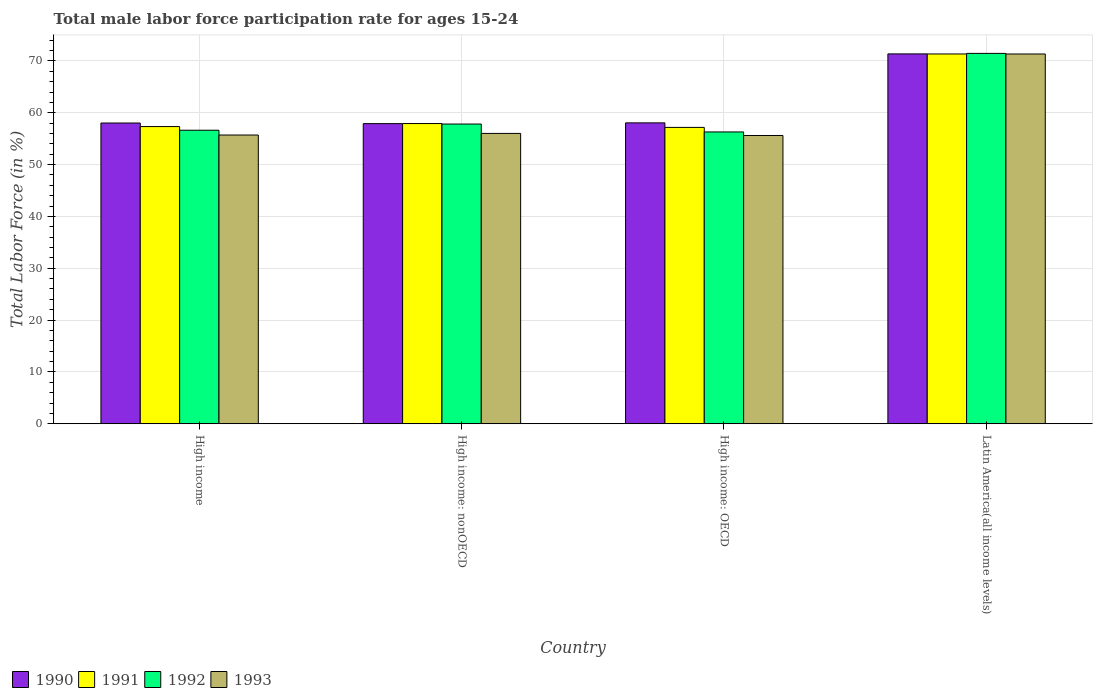How many different coloured bars are there?
Make the answer very short. 4. How many groups of bars are there?
Provide a succinct answer. 4. Are the number of bars on each tick of the X-axis equal?
Your answer should be compact. Yes. How many bars are there on the 1st tick from the left?
Offer a very short reply. 4. How many bars are there on the 3rd tick from the right?
Keep it short and to the point. 4. What is the male labor force participation rate in 1993 in High income: OECD?
Your answer should be compact. 55.62. Across all countries, what is the maximum male labor force participation rate in 1991?
Provide a succinct answer. 71.35. Across all countries, what is the minimum male labor force participation rate in 1993?
Offer a very short reply. 55.62. In which country was the male labor force participation rate in 1991 maximum?
Your answer should be compact. Latin America(all income levels). In which country was the male labor force participation rate in 1993 minimum?
Provide a succinct answer. High income: OECD. What is the total male labor force participation rate in 1991 in the graph?
Give a very brief answer. 243.8. What is the difference between the male labor force participation rate in 1990 in High income: OECD and that in Latin America(all income levels)?
Give a very brief answer. -13.31. What is the difference between the male labor force participation rate in 1991 in High income and the male labor force participation rate in 1992 in High income: nonOECD?
Your response must be concise. -0.49. What is the average male labor force participation rate in 1992 per country?
Your answer should be very brief. 60.56. What is the difference between the male labor force participation rate of/in 1991 and male labor force participation rate of/in 1992 in High income: OECD?
Provide a short and direct response. 0.88. What is the ratio of the male labor force participation rate in 1993 in High income to that in High income: nonOECD?
Your response must be concise. 0.99. Is the difference between the male labor force participation rate in 1991 in High income and High income: OECD greater than the difference between the male labor force participation rate in 1992 in High income and High income: OECD?
Give a very brief answer. No. What is the difference between the highest and the second highest male labor force participation rate in 1992?
Your answer should be compact. -1.2. What is the difference between the highest and the lowest male labor force participation rate in 1992?
Make the answer very short. 15.16. Is the sum of the male labor force participation rate in 1992 in High income: nonOECD and Latin America(all income levels) greater than the maximum male labor force participation rate in 1991 across all countries?
Provide a short and direct response. Yes. What does the 3rd bar from the right in High income represents?
Offer a very short reply. 1991. Is it the case that in every country, the sum of the male labor force participation rate in 1992 and male labor force participation rate in 1990 is greater than the male labor force participation rate in 1993?
Ensure brevity in your answer.  Yes. How many countries are there in the graph?
Your response must be concise. 4. Are the values on the major ticks of Y-axis written in scientific E-notation?
Provide a short and direct response. No. Does the graph contain any zero values?
Your answer should be very brief. No. What is the title of the graph?
Offer a very short reply. Total male labor force participation rate for ages 15-24. Does "1984" appear as one of the legend labels in the graph?
Offer a very short reply. No. What is the label or title of the X-axis?
Your answer should be very brief. Country. What is the Total Labor Force (in %) of 1990 in High income?
Your answer should be very brief. 58.03. What is the Total Labor Force (in %) of 1991 in High income?
Ensure brevity in your answer.  57.34. What is the Total Labor Force (in %) in 1992 in High income?
Give a very brief answer. 56.64. What is the Total Labor Force (in %) in 1993 in High income?
Provide a short and direct response. 55.71. What is the Total Labor Force (in %) in 1990 in High income: nonOECD?
Your answer should be compact. 57.91. What is the Total Labor Force (in %) in 1991 in High income: nonOECD?
Keep it short and to the point. 57.92. What is the Total Labor Force (in %) in 1992 in High income: nonOECD?
Make the answer very short. 57.83. What is the Total Labor Force (in %) of 1993 in High income: nonOECD?
Make the answer very short. 56.02. What is the Total Labor Force (in %) in 1990 in High income: OECD?
Keep it short and to the point. 58.06. What is the Total Labor Force (in %) in 1991 in High income: OECD?
Make the answer very short. 57.18. What is the Total Labor Force (in %) of 1992 in High income: OECD?
Make the answer very short. 56.31. What is the Total Labor Force (in %) of 1993 in High income: OECD?
Give a very brief answer. 55.62. What is the Total Labor Force (in %) of 1990 in Latin America(all income levels)?
Make the answer very short. 71.36. What is the Total Labor Force (in %) in 1991 in Latin America(all income levels)?
Your answer should be very brief. 71.35. What is the Total Labor Force (in %) in 1992 in Latin America(all income levels)?
Provide a succinct answer. 71.46. What is the Total Labor Force (in %) in 1993 in Latin America(all income levels)?
Your answer should be very brief. 71.35. Across all countries, what is the maximum Total Labor Force (in %) in 1990?
Provide a short and direct response. 71.36. Across all countries, what is the maximum Total Labor Force (in %) in 1991?
Make the answer very short. 71.35. Across all countries, what is the maximum Total Labor Force (in %) of 1992?
Keep it short and to the point. 71.46. Across all countries, what is the maximum Total Labor Force (in %) of 1993?
Give a very brief answer. 71.35. Across all countries, what is the minimum Total Labor Force (in %) in 1990?
Your answer should be compact. 57.91. Across all countries, what is the minimum Total Labor Force (in %) in 1991?
Your answer should be very brief. 57.18. Across all countries, what is the minimum Total Labor Force (in %) of 1992?
Keep it short and to the point. 56.31. Across all countries, what is the minimum Total Labor Force (in %) in 1993?
Provide a succinct answer. 55.62. What is the total Total Labor Force (in %) in 1990 in the graph?
Offer a terse response. 245.36. What is the total Total Labor Force (in %) of 1991 in the graph?
Offer a very short reply. 243.8. What is the total Total Labor Force (in %) in 1992 in the graph?
Provide a short and direct response. 242.24. What is the total Total Labor Force (in %) of 1993 in the graph?
Ensure brevity in your answer.  238.7. What is the difference between the Total Labor Force (in %) of 1990 in High income and that in High income: nonOECD?
Your answer should be very brief. 0.11. What is the difference between the Total Labor Force (in %) of 1991 in High income and that in High income: nonOECD?
Ensure brevity in your answer.  -0.58. What is the difference between the Total Labor Force (in %) of 1992 in High income and that in High income: nonOECD?
Make the answer very short. -1.2. What is the difference between the Total Labor Force (in %) in 1993 in High income and that in High income: nonOECD?
Make the answer very short. -0.31. What is the difference between the Total Labor Force (in %) in 1990 in High income and that in High income: OECD?
Make the answer very short. -0.03. What is the difference between the Total Labor Force (in %) in 1991 in High income and that in High income: OECD?
Your answer should be very brief. 0.16. What is the difference between the Total Labor Force (in %) in 1992 in High income and that in High income: OECD?
Your answer should be compact. 0.33. What is the difference between the Total Labor Force (in %) in 1993 in High income and that in High income: OECD?
Keep it short and to the point. 0.09. What is the difference between the Total Labor Force (in %) in 1990 in High income and that in Latin America(all income levels)?
Give a very brief answer. -13.34. What is the difference between the Total Labor Force (in %) of 1991 in High income and that in Latin America(all income levels)?
Keep it short and to the point. -14.01. What is the difference between the Total Labor Force (in %) in 1992 in High income and that in Latin America(all income levels)?
Your answer should be compact. -14.83. What is the difference between the Total Labor Force (in %) in 1993 in High income and that in Latin America(all income levels)?
Ensure brevity in your answer.  -15.64. What is the difference between the Total Labor Force (in %) of 1990 in High income: nonOECD and that in High income: OECD?
Your answer should be very brief. -0.14. What is the difference between the Total Labor Force (in %) of 1991 in High income: nonOECD and that in High income: OECD?
Give a very brief answer. 0.74. What is the difference between the Total Labor Force (in %) in 1992 in High income: nonOECD and that in High income: OECD?
Provide a succinct answer. 1.53. What is the difference between the Total Labor Force (in %) of 1993 in High income: nonOECD and that in High income: OECD?
Offer a terse response. 0.4. What is the difference between the Total Labor Force (in %) of 1990 in High income: nonOECD and that in Latin America(all income levels)?
Your response must be concise. -13.45. What is the difference between the Total Labor Force (in %) in 1991 in High income: nonOECD and that in Latin America(all income levels)?
Your answer should be very brief. -13.43. What is the difference between the Total Labor Force (in %) in 1992 in High income: nonOECD and that in Latin America(all income levels)?
Your answer should be compact. -13.63. What is the difference between the Total Labor Force (in %) in 1993 in High income: nonOECD and that in Latin America(all income levels)?
Make the answer very short. -15.33. What is the difference between the Total Labor Force (in %) in 1990 in High income: OECD and that in Latin America(all income levels)?
Give a very brief answer. -13.31. What is the difference between the Total Labor Force (in %) of 1991 in High income: OECD and that in Latin America(all income levels)?
Offer a very short reply. -14.17. What is the difference between the Total Labor Force (in %) in 1992 in High income: OECD and that in Latin America(all income levels)?
Ensure brevity in your answer.  -15.16. What is the difference between the Total Labor Force (in %) in 1993 in High income: OECD and that in Latin America(all income levels)?
Make the answer very short. -15.73. What is the difference between the Total Labor Force (in %) of 1990 in High income and the Total Labor Force (in %) of 1991 in High income: nonOECD?
Make the answer very short. 0.1. What is the difference between the Total Labor Force (in %) of 1990 in High income and the Total Labor Force (in %) of 1992 in High income: nonOECD?
Offer a terse response. 0.19. What is the difference between the Total Labor Force (in %) in 1990 in High income and the Total Labor Force (in %) in 1993 in High income: nonOECD?
Your answer should be compact. 2. What is the difference between the Total Labor Force (in %) in 1991 in High income and the Total Labor Force (in %) in 1992 in High income: nonOECD?
Offer a very short reply. -0.49. What is the difference between the Total Labor Force (in %) in 1991 in High income and the Total Labor Force (in %) in 1993 in High income: nonOECD?
Provide a short and direct response. 1.32. What is the difference between the Total Labor Force (in %) of 1992 in High income and the Total Labor Force (in %) of 1993 in High income: nonOECD?
Your answer should be very brief. 0.61. What is the difference between the Total Labor Force (in %) in 1990 in High income and the Total Labor Force (in %) in 1991 in High income: OECD?
Your response must be concise. 0.84. What is the difference between the Total Labor Force (in %) of 1990 in High income and the Total Labor Force (in %) of 1992 in High income: OECD?
Offer a very short reply. 1.72. What is the difference between the Total Labor Force (in %) of 1990 in High income and the Total Labor Force (in %) of 1993 in High income: OECD?
Make the answer very short. 2.4. What is the difference between the Total Labor Force (in %) in 1991 in High income and the Total Labor Force (in %) in 1992 in High income: OECD?
Provide a short and direct response. 1.04. What is the difference between the Total Labor Force (in %) in 1991 in High income and the Total Labor Force (in %) in 1993 in High income: OECD?
Provide a short and direct response. 1.72. What is the difference between the Total Labor Force (in %) of 1992 in High income and the Total Labor Force (in %) of 1993 in High income: OECD?
Keep it short and to the point. 1.01. What is the difference between the Total Labor Force (in %) of 1990 in High income and the Total Labor Force (in %) of 1991 in Latin America(all income levels)?
Offer a terse response. -13.33. What is the difference between the Total Labor Force (in %) in 1990 in High income and the Total Labor Force (in %) in 1992 in Latin America(all income levels)?
Your response must be concise. -13.44. What is the difference between the Total Labor Force (in %) of 1990 in High income and the Total Labor Force (in %) of 1993 in Latin America(all income levels)?
Your response must be concise. -13.32. What is the difference between the Total Labor Force (in %) in 1991 in High income and the Total Labor Force (in %) in 1992 in Latin America(all income levels)?
Give a very brief answer. -14.12. What is the difference between the Total Labor Force (in %) in 1991 in High income and the Total Labor Force (in %) in 1993 in Latin America(all income levels)?
Ensure brevity in your answer.  -14.01. What is the difference between the Total Labor Force (in %) in 1992 in High income and the Total Labor Force (in %) in 1993 in Latin America(all income levels)?
Offer a very short reply. -14.71. What is the difference between the Total Labor Force (in %) in 1990 in High income: nonOECD and the Total Labor Force (in %) in 1991 in High income: OECD?
Provide a succinct answer. 0.73. What is the difference between the Total Labor Force (in %) in 1990 in High income: nonOECD and the Total Labor Force (in %) in 1992 in High income: OECD?
Your response must be concise. 1.61. What is the difference between the Total Labor Force (in %) in 1990 in High income: nonOECD and the Total Labor Force (in %) in 1993 in High income: OECD?
Your answer should be compact. 2.29. What is the difference between the Total Labor Force (in %) in 1991 in High income: nonOECD and the Total Labor Force (in %) in 1992 in High income: OECD?
Offer a very short reply. 1.62. What is the difference between the Total Labor Force (in %) of 1991 in High income: nonOECD and the Total Labor Force (in %) of 1993 in High income: OECD?
Make the answer very short. 2.3. What is the difference between the Total Labor Force (in %) of 1992 in High income: nonOECD and the Total Labor Force (in %) of 1993 in High income: OECD?
Provide a short and direct response. 2.21. What is the difference between the Total Labor Force (in %) in 1990 in High income: nonOECD and the Total Labor Force (in %) in 1991 in Latin America(all income levels)?
Keep it short and to the point. -13.44. What is the difference between the Total Labor Force (in %) in 1990 in High income: nonOECD and the Total Labor Force (in %) in 1992 in Latin America(all income levels)?
Ensure brevity in your answer.  -13.55. What is the difference between the Total Labor Force (in %) in 1990 in High income: nonOECD and the Total Labor Force (in %) in 1993 in Latin America(all income levels)?
Provide a succinct answer. -13.44. What is the difference between the Total Labor Force (in %) in 1991 in High income: nonOECD and the Total Labor Force (in %) in 1992 in Latin America(all income levels)?
Ensure brevity in your answer.  -13.54. What is the difference between the Total Labor Force (in %) in 1991 in High income: nonOECD and the Total Labor Force (in %) in 1993 in Latin America(all income levels)?
Provide a succinct answer. -13.43. What is the difference between the Total Labor Force (in %) of 1992 in High income: nonOECD and the Total Labor Force (in %) of 1993 in Latin America(all income levels)?
Offer a terse response. -13.52. What is the difference between the Total Labor Force (in %) of 1990 in High income: OECD and the Total Labor Force (in %) of 1991 in Latin America(all income levels)?
Ensure brevity in your answer.  -13.3. What is the difference between the Total Labor Force (in %) in 1990 in High income: OECD and the Total Labor Force (in %) in 1992 in Latin America(all income levels)?
Give a very brief answer. -13.41. What is the difference between the Total Labor Force (in %) in 1990 in High income: OECD and the Total Labor Force (in %) in 1993 in Latin America(all income levels)?
Your answer should be very brief. -13.29. What is the difference between the Total Labor Force (in %) of 1991 in High income: OECD and the Total Labor Force (in %) of 1992 in Latin America(all income levels)?
Make the answer very short. -14.28. What is the difference between the Total Labor Force (in %) in 1991 in High income: OECD and the Total Labor Force (in %) in 1993 in Latin America(all income levels)?
Your answer should be very brief. -14.17. What is the difference between the Total Labor Force (in %) of 1992 in High income: OECD and the Total Labor Force (in %) of 1993 in Latin America(all income levels)?
Your answer should be compact. -15.04. What is the average Total Labor Force (in %) of 1990 per country?
Provide a short and direct response. 61.34. What is the average Total Labor Force (in %) of 1991 per country?
Offer a terse response. 60.95. What is the average Total Labor Force (in %) of 1992 per country?
Your answer should be compact. 60.56. What is the average Total Labor Force (in %) of 1993 per country?
Provide a short and direct response. 59.68. What is the difference between the Total Labor Force (in %) in 1990 and Total Labor Force (in %) in 1991 in High income?
Provide a short and direct response. 0.68. What is the difference between the Total Labor Force (in %) of 1990 and Total Labor Force (in %) of 1992 in High income?
Keep it short and to the point. 1.39. What is the difference between the Total Labor Force (in %) of 1990 and Total Labor Force (in %) of 1993 in High income?
Your answer should be compact. 2.32. What is the difference between the Total Labor Force (in %) of 1991 and Total Labor Force (in %) of 1992 in High income?
Provide a succinct answer. 0.71. What is the difference between the Total Labor Force (in %) in 1991 and Total Labor Force (in %) in 1993 in High income?
Make the answer very short. 1.63. What is the difference between the Total Labor Force (in %) in 1992 and Total Labor Force (in %) in 1993 in High income?
Give a very brief answer. 0.93. What is the difference between the Total Labor Force (in %) in 1990 and Total Labor Force (in %) in 1991 in High income: nonOECD?
Provide a succinct answer. -0.01. What is the difference between the Total Labor Force (in %) of 1990 and Total Labor Force (in %) of 1992 in High income: nonOECD?
Your response must be concise. 0.08. What is the difference between the Total Labor Force (in %) in 1990 and Total Labor Force (in %) in 1993 in High income: nonOECD?
Your answer should be very brief. 1.89. What is the difference between the Total Labor Force (in %) in 1991 and Total Labor Force (in %) in 1992 in High income: nonOECD?
Your answer should be very brief. 0.09. What is the difference between the Total Labor Force (in %) in 1991 and Total Labor Force (in %) in 1993 in High income: nonOECD?
Offer a terse response. 1.9. What is the difference between the Total Labor Force (in %) in 1992 and Total Labor Force (in %) in 1993 in High income: nonOECD?
Give a very brief answer. 1.81. What is the difference between the Total Labor Force (in %) of 1990 and Total Labor Force (in %) of 1991 in High income: OECD?
Give a very brief answer. 0.87. What is the difference between the Total Labor Force (in %) of 1990 and Total Labor Force (in %) of 1992 in High income: OECD?
Your answer should be compact. 1.75. What is the difference between the Total Labor Force (in %) in 1990 and Total Labor Force (in %) in 1993 in High income: OECD?
Provide a succinct answer. 2.43. What is the difference between the Total Labor Force (in %) of 1991 and Total Labor Force (in %) of 1992 in High income: OECD?
Provide a short and direct response. 0.88. What is the difference between the Total Labor Force (in %) of 1991 and Total Labor Force (in %) of 1993 in High income: OECD?
Make the answer very short. 1.56. What is the difference between the Total Labor Force (in %) in 1992 and Total Labor Force (in %) in 1993 in High income: OECD?
Provide a short and direct response. 0.68. What is the difference between the Total Labor Force (in %) in 1990 and Total Labor Force (in %) in 1991 in Latin America(all income levels)?
Provide a succinct answer. 0.01. What is the difference between the Total Labor Force (in %) of 1990 and Total Labor Force (in %) of 1992 in Latin America(all income levels)?
Provide a succinct answer. -0.1. What is the difference between the Total Labor Force (in %) in 1990 and Total Labor Force (in %) in 1993 in Latin America(all income levels)?
Your answer should be compact. 0.02. What is the difference between the Total Labor Force (in %) of 1991 and Total Labor Force (in %) of 1992 in Latin America(all income levels)?
Give a very brief answer. -0.11. What is the difference between the Total Labor Force (in %) in 1991 and Total Labor Force (in %) in 1993 in Latin America(all income levels)?
Ensure brevity in your answer.  0. What is the difference between the Total Labor Force (in %) in 1992 and Total Labor Force (in %) in 1993 in Latin America(all income levels)?
Offer a very short reply. 0.11. What is the ratio of the Total Labor Force (in %) of 1992 in High income to that in High income: nonOECD?
Keep it short and to the point. 0.98. What is the ratio of the Total Labor Force (in %) of 1993 in High income to that in High income: nonOECD?
Provide a succinct answer. 0.99. What is the ratio of the Total Labor Force (in %) in 1992 in High income to that in High income: OECD?
Your response must be concise. 1.01. What is the ratio of the Total Labor Force (in %) in 1993 in High income to that in High income: OECD?
Provide a short and direct response. 1. What is the ratio of the Total Labor Force (in %) of 1990 in High income to that in Latin America(all income levels)?
Ensure brevity in your answer.  0.81. What is the ratio of the Total Labor Force (in %) of 1991 in High income to that in Latin America(all income levels)?
Offer a terse response. 0.8. What is the ratio of the Total Labor Force (in %) of 1992 in High income to that in Latin America(all income levels)?
Provide a short and direct response. 0.79. What is the ratio of the Total Labor Force (in %) in 1993 in High income to that in Latin America(all income levels)?
Provide a short and direct response. 0.78. What is the ratio of the Total Labor Force (in %) of 1990 in High income: nonOECD to that in High income: OECD?
Provide a succinct answer. 1. What is the ratio of the Total Labor Force (in %) of 1992 in High income: nonOECD to that in High income: OECD?
Make the answer very short. 1.03. What is the ratio of the Total Labor Force (in %) of 1990 in High income: nonOECD to that in Latin America(all income levels)?
Your response must be concise. 0.81. What is the ratio of the Total Labor Force (in %) of 1991 in High income: nonOECD to that in Latin America(all income levels)?
Keep it short and to the point. 0.81. What is the ratio of the Total Labor Force (in %) in 1992 in High income: nonOECD to that in Latin America(all income levels)?
Provide a succinct answer. 0.81. What is the ratio of the Total Labor Force (in %) of 1993 in High income: nonOECD to that in Latin America(all income levels)?
Your answer should be compact. 0.79. What is the ratio of the Total Labor Force (in %) in 1990 in High income: OECD to that in Latin America(all income levels)?
Make the answer very short. 0.81. What is the ratio of the Total Labor Force (in %) of 1991 in High income: OECD to that in Latin America(all income levels)?
Your answer should be very brief. 0.8. What is the ratio of the Total Labor Force (in %) of 1992 in High income: OECD to that in Latin America(all income levels)?
Your answer should be compact. 0.79. What is the ratio of the Total Labor Force (in %) of 1993 in High income: OECD to that in Latin America(all income levels)?
Give a very brief answer. 0.78. What is the difference between the highest and the second highest Total Labor Force (in %) of 1990?
Your response must be concise. 13.31. What is the difference between the highest and the second highest Total Labor Force (in %) of 1991?
Provide a short and direct response. 13.43. What is the difference between the highest and the second highest Total Labor Force (in %) of 1992?
Offer a terse response. 13.63. What is the difference between the highest and the second highest Total Labor Force (in %) of 1993?
Keep it short and to the point. 15.33. What is the difference between the highest and the lowest Total Labor Force (in %) in 1990?
Offer a very short reply. 13.45. What is the difference between the highest and the lowest Total Labor Force (in %) in 1991?
Keep it short and to the point. 14.17. What is the difference between the highest and the lowest Total Labor Force (in %) of 1992?
Your answer should be compact. 15.16. What is the difference between the highest and the lowest Total Labor Force (in %) of 1993?
Your response must be concise. 15.73. 